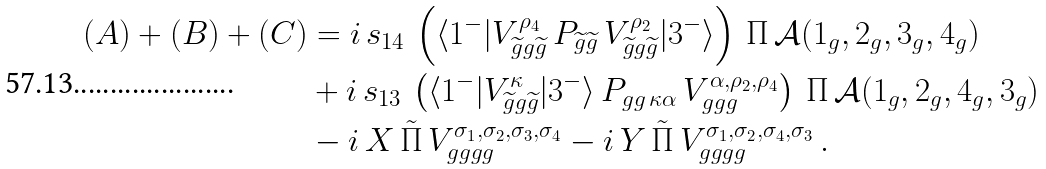<formula> <loc_0><loc_0><loc_500><loc_500>( A ) + ( B ) + ( C ) & = i \, s _ { 1 4 } \, \left ( \langle 1 ^ { - } | V _ { \widetilde { g } g \widetilde { g } } ^ { \rho _ { 4 } } \, P _ { \widetilde { g } \widetilde { g } } \, V _ { \widetilde { g } g \widetilde { g } } ^ { \rho _ { 2 } } | 3 ^ { - } \rangle \right ) \, \Pi \, \mathcal { A } ( 1 _ { g } , 2 _ { g } , 3 _ { g } , 4 _ { g } ) \\ & + i \, s _ { 1 3 } \, \left ( \langle 1 ^ { - } | V _ { \widetilde { g } g \widetilde { g } } ^ { \kappa } | 3 ^ { - } \rangle \, P _ { g g \, \kappa \alpha } \, V _ { g g g } ^ { \alpha , \rho _ { 2 } , \rho _ { 4 } } \right ) \, \Pi \, \mathcal { A } ( 1 _ { g } , 2 _ { g } , 4 _ { g } , 3 _ { g } ) \\ & - i \, X \, \tilde { \Pi } \, V ^ { \sigma _ { 1 } , \sigma _ { 2 } , \sigma _ { 3 } , \sigma _ { 4 } } _ { g g g g } - i \, Y \, \tilde { \Pi } \, V ^ { \sigma _ { 1 } , \sigma _ { 2 } , \sigma _ { 4 } , \sigma _ { 3 } } _ { g g g g } \, .</formula> 